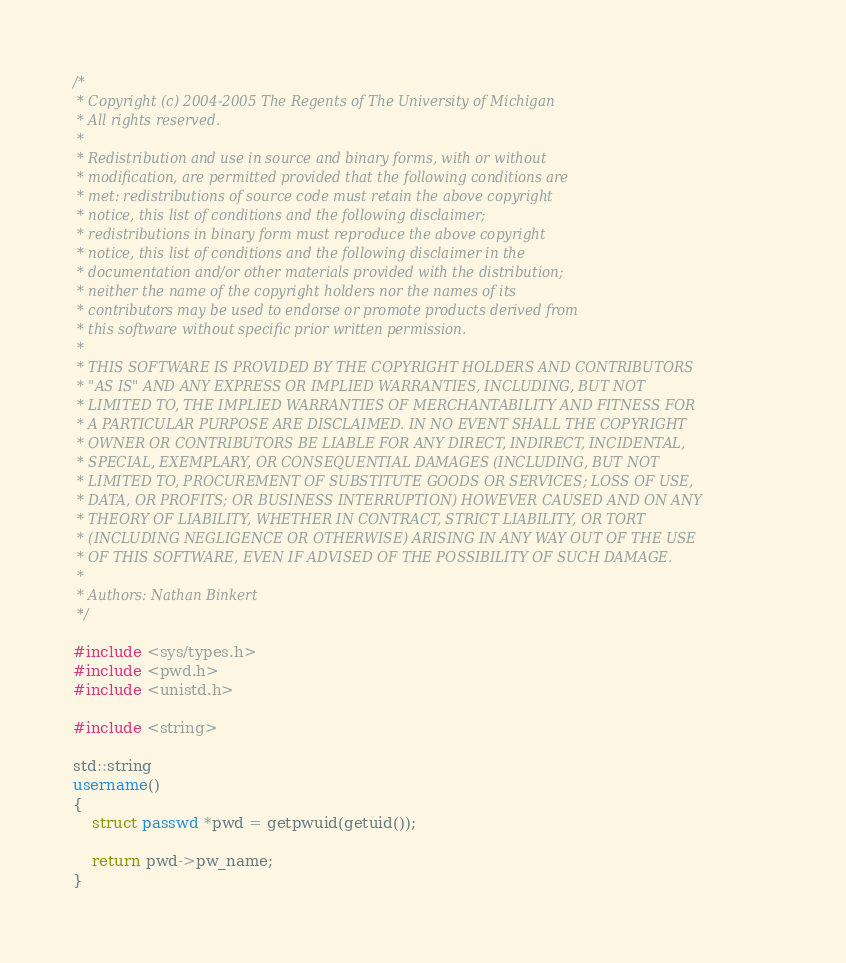<code> <loc_0><loc_0><loc_500><loc_500><_C++_>/*
 * Copyright (c) 2004-2005 The Regents of The University of Michigan
 * All rights reserved.
 *
 * Redistribution and use in source and binary forms, with or without
 * modification, are permitted provided that the following conditions are
 * met: redistributions of source code must retain the above copyright
 * notice, this list of conditions and the following disclaimer;
 * redistributions in binary form must reproduce the above copyright
 * notice, this list of conditions and the following disclaimer in the
 * documentation and/or other materials provided with the distribution;
 * neither the name of the copyright holders nor the names of its
 * contributors may be used to endorse or promote products derived from
 * this software without specific prior written permission.
 *
 * THIS SOFTWARE IS PROVIDED BY THE COPYRIGHT HOLDERS AND CONTRIBUTORS
 * "AS IS" AND ANY EXPRESS OR IMPLIED WARRANTIES, INCLUDING, BUT NOT
 * LIMITED TO, THE IMPLIED WARRANTIES OF MERCHANTABILITY AND FITNESS FOR
 * A PARTICULAR PURPOSE ARE DISCLAIMED. IN NO EVENT SHALL THE COPYRIGHT
 * OWNER OR CONTRIBUTORS BE LIABLE FOR ANY DIRECT, INDIRECT, INCIDENTAL,
 * SPECIAL, EXEMPLARY, OR CONSEQUENTIAL DAMAGES (INCLUDING, BUT NOT
 * LIMITED TO, PROCUREMENT OF SUBSTITUTE GOODS OR SERVICES; LOSS OF USE,
 * DATA, OR PROFITS; OR BUSINESS INTERRUPTION) HOWEVER CAUSED AND ON ANY
 * THEORY OF LIABILITY, WHETHER IN CONTRACT, STRICT LIABILITY, OR TORT
 * (INCLUDING NEGLIGENCE OR OTHERWISE) ARISING IN ANY WAY OUT OF THE USE
 * OF THIS SOFTWARE, EVEN IF ADVISED OF THE POSSIBILITY OF SUCH DAMAGE.
 *
 * Authors: Nathan Binkert
 */

#include <sys/types.h>
#include <pwd.h>
#include <unistd.h>

#include <string>

std::string
username()
{
    struct passwd *pwd = getpwuid(getuid());

    return pwd->pw_name;
}
</code> 